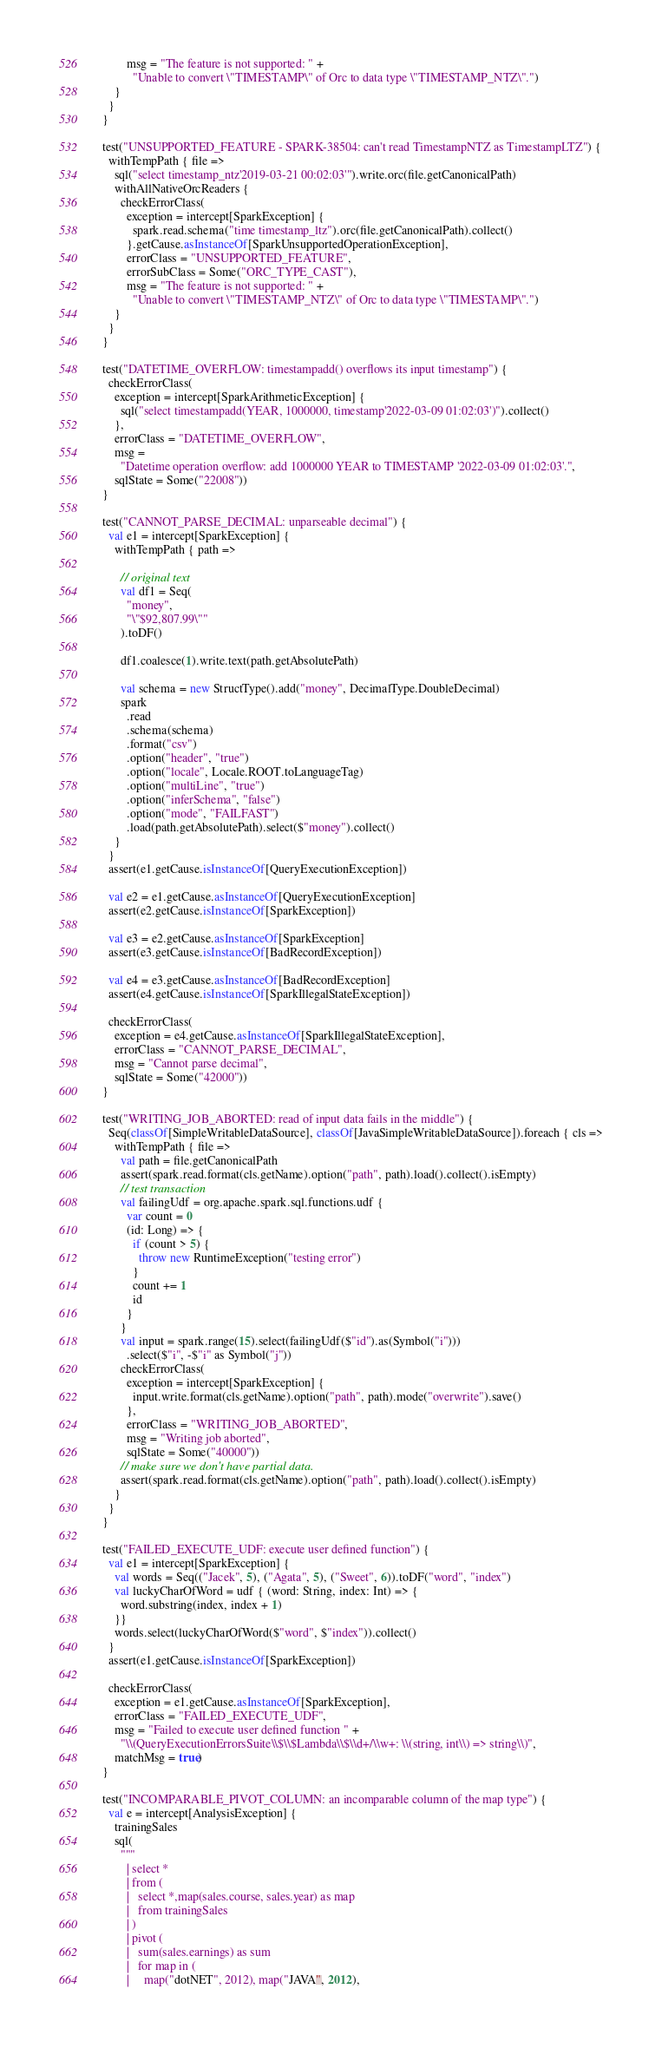<code> <loc_0><loc_0><loc_500><loc_500><_Scala_>          msg = "The feature is not supported: " +
            "Unable to convert \"TIMESTAMP\" of Orc to data type \"TIMESTAMP_NTZ\".")
      }
    }
  }

  test("UNSUPPORTED_FEATURE - SPARK-38504: can't read TimestampNTZ as TimestampLTZ") {
    withTempPath { file =>
      sql("select timestamp_ntz'2019-03-21 00:02:03'").write.orc(file.getCanonicalPath)
      withAllNativeOrcReaders {
        checkErrorClass(
          exception = intercept[SparkException] {
            spark.read.schema("time timestamp_ltz").orc(file.getCanonicalPath).collect()
          }.getCause.asInstanceOf[SparkUnsupportedOperationException],
          errorClass = "UNSUPPORTED_FEATURE",
          errorSubClass = Some("ORC_TYPE_CAST"),
          msg = "The feature is not supported: " +
            "Unable to convert \"TIMESTAMP_NTZ\" of Orc to data type \"TIMESTAMP\".")
      }
    }
  }

  test("DATETIME_OVERFLOW: timestampadd() overflows its input timestamp") {
    checkErrorClass(
      exception = intercept[SparkArithmeticException] {
        sql("select timestampadd(YEAR, 1000000, timestamp'2022-03-09 01:02:03')").collect()
      },
      errorClass = "DATETIME_OVERFLOW",
      msg =
        "Datetime operation overflow: add 1000000 YEAR to TIMESTAMP '2022-03-09 01:02:03'.",
      sqlState = Some("22008"))
  }

  test("CANNOT_PARSE_DECIMAL: unparseable decimal") {
    val e1 = intercept[SparkException] {
      withTempPath { path =>

        // original text
        val df1 = Seq(
          "money",
          "\"$92,807.99\""
        ).toDF()

        df1.coalesce(1).write.text(path.getAbsolutePath)

        val schema = new StructType().add("money", DecimalType.DoubleDecimal)
        spark
          .read
          .schema(schema)
          .format("csv")
          .option("header", "true")
          .option("locale", Locale.ROOT.toLanguageTag)
          .option("multiLine", "true")
          .option("inferSchema", "false")
          .option("mode", "FAILFAST")
          .load(path.getAbsolutePath).select($"money").collect()
      }
    }
    assert(e1.getCause.isInstanceOf[QueryExecutionException])

    val e2 = e1.getCause.asInstanceOf[QueryExecutionException]
    assert(e2.getCause.isInstanceOf[SparkException])

    val e3 = e2.getCause.asInstanceOf[SparkException]
    assert(e3.getCause.isInstanceOf[BadRecordException])

    val e4 = e3.getCause.asInstanceOf[BadRecordException]
    assert(e4.getCause.isInstanceOf[SparkIllegalStateException])

    checkErrorClass(
      exception = e4.getCause.asInstanceOf[SparkIllegalStateException],
      errorClass = "CANNOT_PARSE_DECIMAL",
      msg = "Cannot parse decimal",
      sqlState = Some("42000"))
  }

  test("WRITING_JOB_ABORTED: read of input data fails in the middle") {
    Seq(classOf[SimpleWritableDataSource], classOf[JavaSimpleWritableDataSource]).foreach { cls =>
      withTempPath { file =>
        val path = file.getCanonicalPath
        assert(spark.read.format(cls.getName).option("path", path).load().collect().isEmpty)
        // test transaction
        val failingUdf = org.apache.spark.sql.functions.udf {
          var count = 0
          (id: Long) => {
            if (count > 5) {
              throw new RuntimeException("testing error")
            }
            count += 1
            id
          }
        }
        val input = spark.range(15).select(failingUdf($"id").as(Symbol("i")))
          .select($"i", -$"i" as Symbol("j"))
        checkErrorClass(
          exception = intercept[SparkException] {
            input.write.format(cls.getName).option("path", path).mode("overwrite").save()
          },
          errorClass = "WRITING_JOB_ABORTED",
          msg = "Writing job aborted",
          sqlState = Some("40000"))
        // make sure we don't have partial data.
        assert(spark.read.format(cls.getName).option("path", path).load().collect().isEmpty)
      }
    }
  }

  test("FAILED_EXECUTE_UDF: execute user defined function") {
    val e1 = intercept[SparkException] {
      val words = Seq(("Jacek", 5), ("Agata", 5), ("Sweet", 6)).toDF("word", "index")
      val luckyCharOfWord = udf { (word: String, index: Int) => {
        word.substring(index, index + 1)
      }}
      words.select(luckyCharOfWord($"word", $"index")).collect()
    }
    assert(e1.getCause.isInstanceOf[SparkException])

    checkErrorClass(
      exception = e1.getCause.asInstanceOf[SparkException],
      errorClass = "FAILED_EXECUTE_UDF",
      msg = "Failed to execute user defined function " +
        "\\(QueryExecutionErrorsSuite\\$\\$Lambda\\$\\d+/\\w+: \\(string, int\\) => string\\)",
      matchMsg = true)
  }

  test("INCOMPARABLE_PIVOT_COLUMN: an incomparable column of the map type") {
    val e = intercept[AnalysisException] {
      trainingSales
      sql(
        """
          | select *
          | from (
          |   select *,map(sales.course, sales.year) as map
          |   from trainingSales
          | )
          | pivot (
          |   sum(sales.earnings) as sum
          |   for map in (
          |     map("dotNET", 2012), map("JAVA", 2012),</code> 